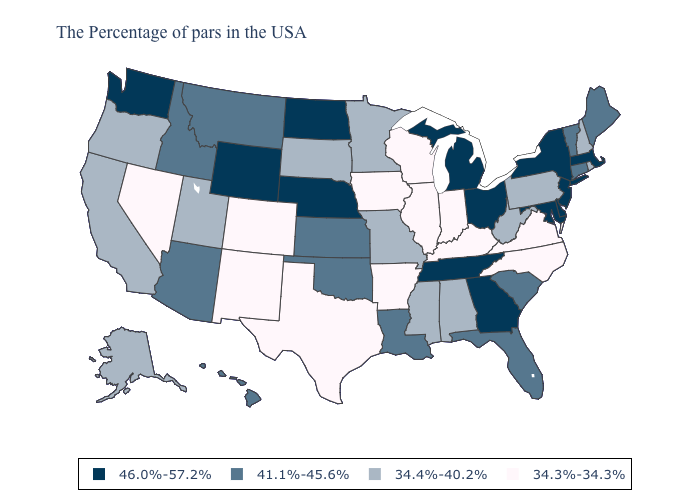Name the states that have a value in the range 41.1%-45.6%?
Write a very short answer. Maine, Vermont, Connecticut, South Carolina, Florida, Louisiana, Kansas, Oklahoma, Montana, Arizona, Idaho, Hawaii. Name the states that have a value in the range 34.4%-40.2%?
Give a very brief answer. Rhode Island, New Hampshire, Pennsylvania, West Virginia, Alabama, Mississippi, Missouri, Minnesota, South Dakota, Utah, California, Oregon, Alaska. What is the highest value in states that border California?
Be succinct. 41.1%-45.6%. Does the map have missing data?
Short answer required. No. Does Washington have the highest value in the USA?
Keep it brief. Yes. What is the value of Oklahoma?
Keep it brief. 41.1%-45.6%. What is the value of Colorado?
Answer briefly. 34.3%-34.3%. What is the value of Pennsylvania?
Give a very brief answer. 34.4%-40.2%. What is the value of Alabama?
Write a very short answer. 34.4%-40.2%. Name the states that have a value in the range 41.1%-45.6%?
Give a very brief answer. Maine, Vermont, Connecticut, South Carolina, Florida, Louisiana, Kansas, Oklahoma, Montana, Arizona, Idaho, Hawaii. Does Florida have a higher value than North Carolina?
Short answer required. Yes. Which states have the lowest value in the USA?
Keep it brief. Virginia, North Carolina, Kentucky, Indiana, Wisconsin, Illinois, Arkansas, Iowa, Texas, Colorado, New Mexico, Nevada. What is the highest value in states that border New Hampshire?
Write a very short answer. 46.0%-57.2%. Name the states that have a value in the range 41.1%-45.6%?
Short answer required. Maine, Vermont, Connecticut, South Carolina, Florida, Louisiana, Kansas, Oklahoma, Montana, Arizona, Idaho, Hawaii. Name the states that have a value in the range 46.0%-57.2%?
Answer briefly. Massachusetts, New York, New Jersey, Delaware, Maryland, Ohio, Georgia, Michigan, Tennessee, Nebraska, North Dakota, Wyoming, Washington. 